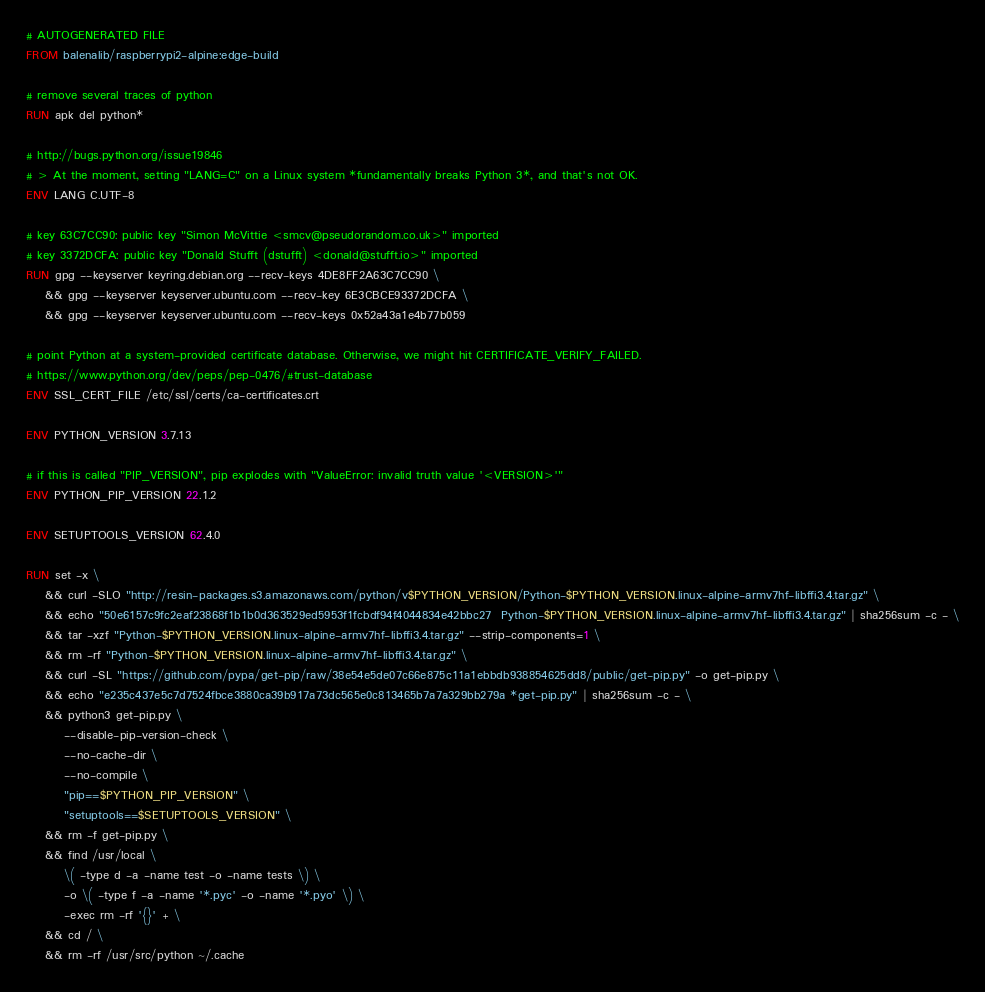<code> <loc_0><loc_0><loc_500><loc_500><_Dockerfile_># AUTOGENERATED FILE
FROM balenalib/raspberrypi2-alpine:edge-build

# remove several traces of python
RUN apk del python*

# http://bugs.python.org/issue19846
# > At the moment, setting "LANG=C" on a Linux system *fundamentally breaks Python 3*, and that's not OK.
ENV LANG C.UTF-8

# key 63C7CC90: public key "Simon McVittie <smcv@pseudorandom.co.uk>" imported
# key 3372DCFA: public key "Donald Stufft (dstufft) <donald@stufft.io>" imported
RUN gpg --keyserver keyring.debian.org --recv-keys 4DE8FF2A63C7CC90 \
	&& gpg --keyserver keyserver.ubuntu.com --recv-key 6E3CBCE93372DCFA \
	&& gpg --keyserver keyserver.ubuntu.com --recv-keys 0x52a43a1e4b77b059

# point Python at a system-provided certificate database. Otherwise, we might hit CERTIFICATE_VERIFY_FAILED.
# https://www.python.org/dev/peps/pep-0476/#trust-database
ENV SSL_CERT_FILE /etc/ssl/certs/ca-certificates.crt

ENV PYTHON_VERSION 3.7.13

# if this is called "PIP_VERSION", pip explodes with "ValueError: invalid truth value '<VERSION>'"
ENV PYTHON_PIP_VERSION 22.1.2

ENV SETUPTOOLS_VERSION 62.4.0

RUN set -x \
	&& curl -SLO "http://resin-packages.s3.amazonaws.com/python/v$PYTHON_VERSION/Python-$PYTHON_VERSION.linux-alpine-armv7hf-libffi3.4.tar.gz" \
	&& echo "50e6157c9fc2eaf23868f1b1b0d363529ed5953f1fcbdf94f4044834e42bbc27  Python-$PYTHON_VERSION.linux-alpine-armv7hf-libffi3.4.tar.gz" | sha256sum -c - \
	&& tar -xzf "Python-$PYTHON_VERSION.linux-alpine-armv7hf-libffi3.4.tar.gz" --strip-components=1 \
	&& rm -rf "Python-$PYTHON_VERSION.linux-alpine-armv7hf-libffi3.4.tar.gz" \
	&& curl -SL "https://github.com/pypa/get-pip/raw/38e54e5de07c66e875c11a1ebbdb938854625dd8/public/get-pip.py" -o get-pip.py \
    && echo "e235c437e5c7d7524fbce3880ca39b917a73dc565e0c813465b7a7a329bb279a *get-pip.py" | sha256sum -c - \
    && python3 get-pip.py \
        --disable-pip-version-check \
        --no-cache-dir \
        --no-compile \
        "pip==$PYTHON_PIP_VERSION" \
        "setuptools==$SETUPTOOLS_VERSION" \
	&& rm -f get-pip.py \
	&& find /usr/local \
		\( -type d -a -name test -o -name tests \) \
		-o \( -type f -a -name '*.pyc' -o -name '*.pyo' \) \
		-exec rm -rf '{}' + \
	&& cd / \
	&& rm -rf /usr/src/python ~/.cache
</code> 